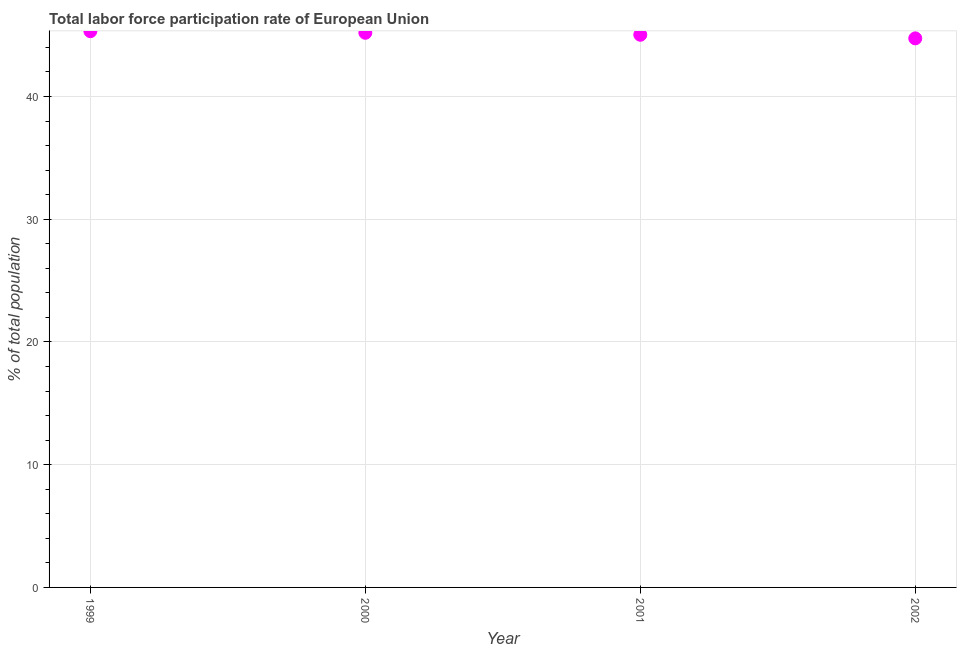What is the total labor force participation rate in 2001?
Your response must be concise. 45.03. Across all years, what is the maximum total labor force participation rate?
Your answer should be compact. 45.32. Across all years, what is the minimum total labor force participation rate?
Give a very brief answer. 44.74. What is the sum of the total labor force participation rate?
Provide a succinct answer. 180.28. What is the difference between the total labor force participation rate in 1999 and 2000?
Ensure brevity in your answer.  0.13. What is the average total labor force participation rate per year?
Give a very brief answer. 45.07. What is the median total labor force participation rate?
Give a very brief answer. 45.11. In how many years, is the total labor force participation rate greater than 14 %?
Offer a very short reply. 4. What is the ratio of the total labor force participation rate in 1999 to that in 2002?
Ensure brevity in your answer.  1.01. Is the difference between the total labor force participation rate in 1999 and 2000 greater than the difference between any two years?
Offer a terse response. No. What is the difference between the highest and the second highest total labor force participation rate?
Offer a very short reply. 0.13. What is the difference between the highest and the lowest total labor force participation rate?
Ensure brevity in your answer.  0.59. How many dotlines are there?
Provide a short and direct response. 1. How many years are there in the graph?
Make the answer very short. 4. Does the graph contain any zero values?
Make the answer very short. No. What is the title of the graph?
Your response must be concise. Total labor force participation rate of European Union. What is the label or title of the Y-axis?
Keep it short and to the point. % of total population. What is the % of total population in 1999?
Your answer should be compact. 45.32. What is the % of total population in 2000?
Keep it short and to the point. 45.19. What is the % of total population in 2001?
Provide a short and direct response. 45.03. What is the % of total population in 2002?
Give a very brief answer. 44.74. What is the difference between the % of total population in 1999 and 2000?
Provide a succinct answer. 0.13. What is the difference between the % of total population in 1999 and 2001?
Make the answer very short. 0.29. What is the difference between the % of total population in 1999 and 2002?
Keep it short and to the point. 0.59. What is the difference between the % of total population in 2000 and 2001?
Give a very brief answer. 0.16. What is the difference between the % of total population in 2000 and 2002?
Provide a short and direct response. 0.45. What is the difference between the % of total population in 2001 and 2002?
Ensure brevity in your answer.  0.29. What is the ratio of the % of total population in 1999 to that in 2000?
Provide a succinct answer. 1. What is the ratio of the % of total population in 1999 to that in 2001?
Your response must be concise. 1.01. What is the ratio of the % of total population in 2000 to that in 2002?
Make the answer very short. 1.01. What is the ratio of the % of total population in 2001 to that in 2002?
Your response must be concise. 1.01. 